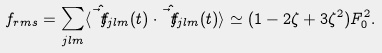<formula> <loc_0><loc_0><loc_500><loc_500>f _ { r m s } = \sum _ { j l m } \langle \hat { \vec { t } { f } } _ { j l m } ( t ) \cdot \hat { \vec { t } { f } } _ { j l m } ( t ) \rangle \simeq ( 1 - 2 \zeta + 3 \zeta ^ { 2 } ) F _ { 0 } ^ { 2 } .</formula> 